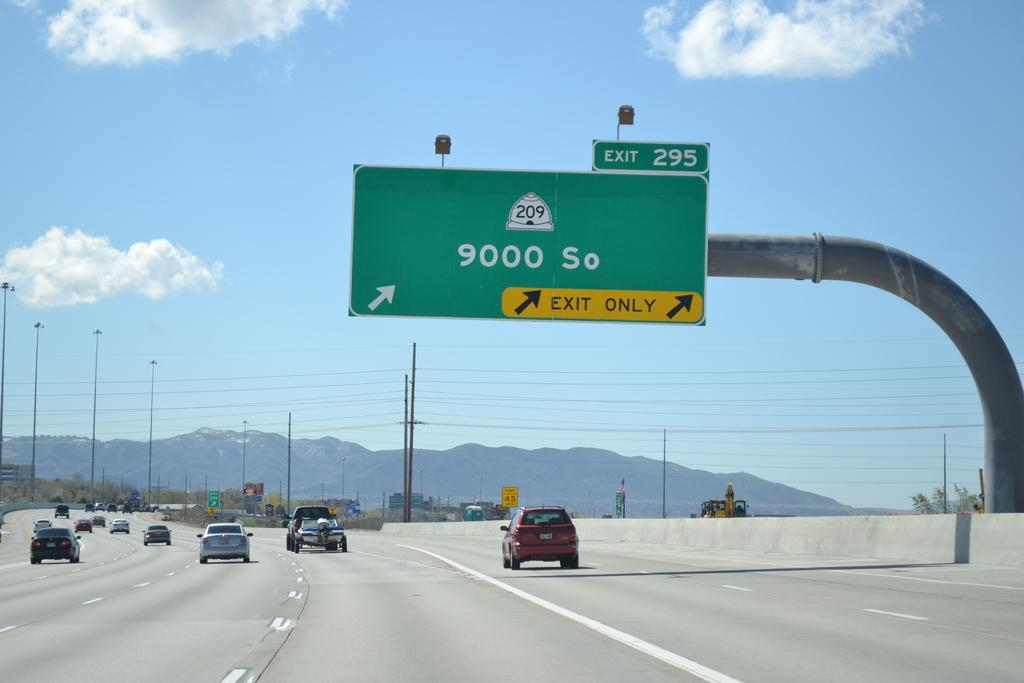<image>
Relay a brief, clear account of the picture shown. A road sign on freeway 209 showing exit 295. 